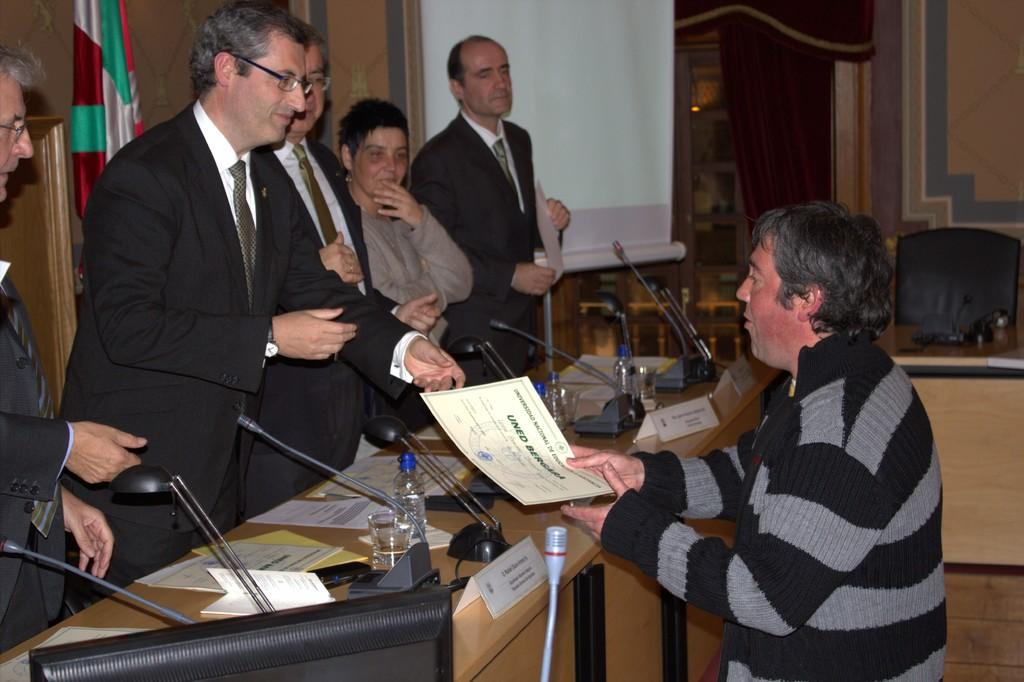<image>
Describe the image concisely. a man in a striped sweater handing a document with uned on it to people 